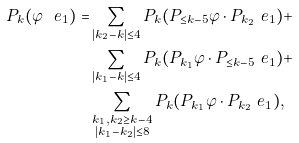Convert formula to latex. <formula><loc_0><loc_0><loc_500><loc_500>P _ { k } ( \varphi \ e _ { 1 } ) = & \sum _ { | k _ { 2 } - k | \leq 4 } P _ { k } ( P _ { \leq k - 5 } \varphi \cdot P _ { k _ { 2 } } \ e _ { 1 } ) + \\ & \sum _ { | k _ { 1 } - k | \leq 4 } P _ { k } ( P _ { k _ { 1 } } \varphi \cdot P _ { \leq k - 5 } \ e _ { 1 } ) + \\ & \sum _ { \substack { k _ { 1 } , k _ { 2 } \geq k - 4 \\ | k _ { 1 } - k _ { 2 } | \leq 8 } } P _ { k } ( P _ { k _ { 1 } } \varphi \cdot P _ { k _ { 2 } } \ e _ { 1 } ) ,</formula> 